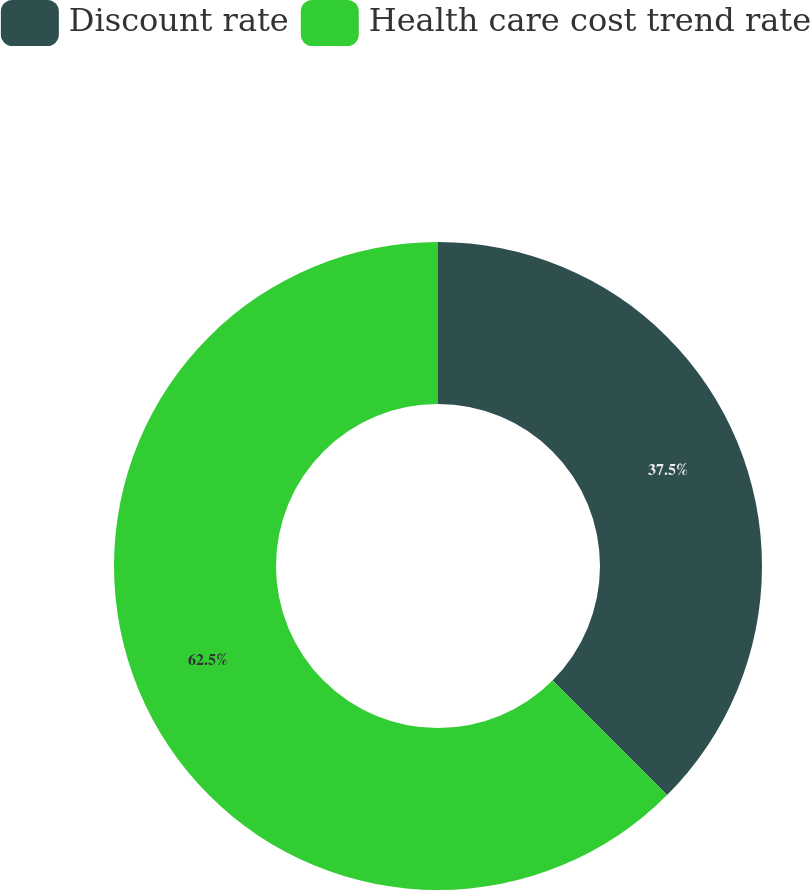<chart> <loc_0><loc_0><loc_500><loc_500><pie_chart><fcel>Discount rate<fcel>Health care cost trend rate<nl><fcel>37.5%<fcel>62.5%<nl></chart> 